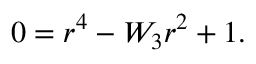Convert formula to latex. <formula><loc_0><loc_0><loc_500><loc_500>\begin{array} { r } { 0 = r ^ { 4 } - W _ { 3 } r ^ { 2 } + 1 . } \end{array}</formula> 